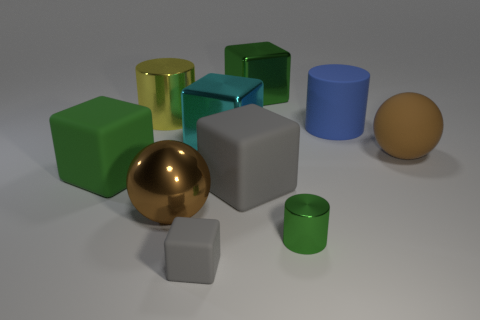Subtract all cyan spheres. How many gray cubes are left? 2 Subtract all green blocks. How many blocks are left? 3 Subtract all big cyan blocks. How many blocks are left? 4 Subtract 3 blocks. How many blocks are left? 2 Subtract all cyan blocks. Subtract all cyan spheres. How many blocks are left? 4 Subtract all cylinders. How many objects are left? 7 Subtract 2 gray blocks. How many objects are left? 8 Subtract all small green metallic cylinders. Subtract all large gray blocks. How many objects are left? 8 Add 9 big gray objects. How many big gray objects are left? 10 Add 6 gray rubber blocks. How many gray rubber blocks exist? 8 